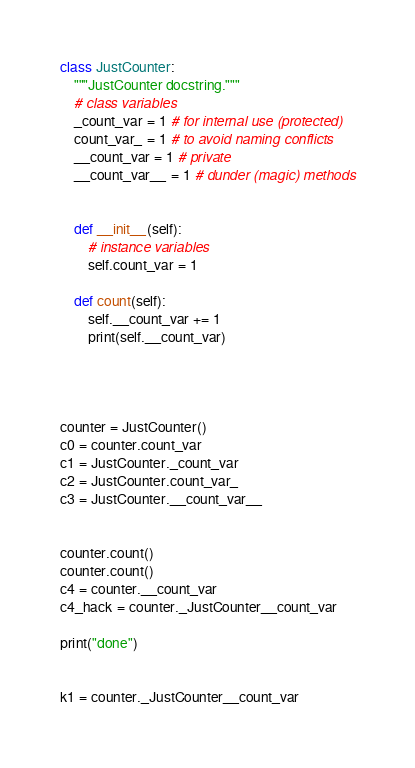Convert code to text. <code><loc_0><loc_0><loc_500><loc_500><_Python_>
class JustCounter:
    """JustCounter docstring."""
    # class variables
    _count_var = 1 # for internal use (protected)
    count_var_ = 1 # to avoid naming conflicts
    __count_var = 1 # private
    __count_var__ = 1 # dunder (magic) methods


    def __init__(self):
        # instance variables
        self.count_var = 1

    def count(self):
        self.__count_var += 1
        print(self.__count_var)




counter = JustCounter()
c0 = counter.count_var
c1 = JustCounter._count_var
c2 = JustCounter.count_var_
c3 = JustCounter.__count_var__


counter.count()
counter.count()
c4 = counter.__count_var
c4_hack = counter._JustCounter__count_var

print("done")


k1 = counter._JustCounter__count_var</code> 